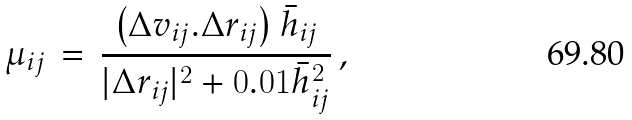Convert formula to latex. <formula><loc_0><loc_0><loc_500><loc_500>\mu _ { i j } \, = \, \frac { \left ( \Delta { v } _ { i j } . \Delta { r } _ { i j } \right ) \bar { h } _ { i j } } { | \Delta { r } _ { i j } | ^ { 2 } + 0 . 0 1 \bar { h } _ { i j } ^ { 2 } } \, ,</formula> 